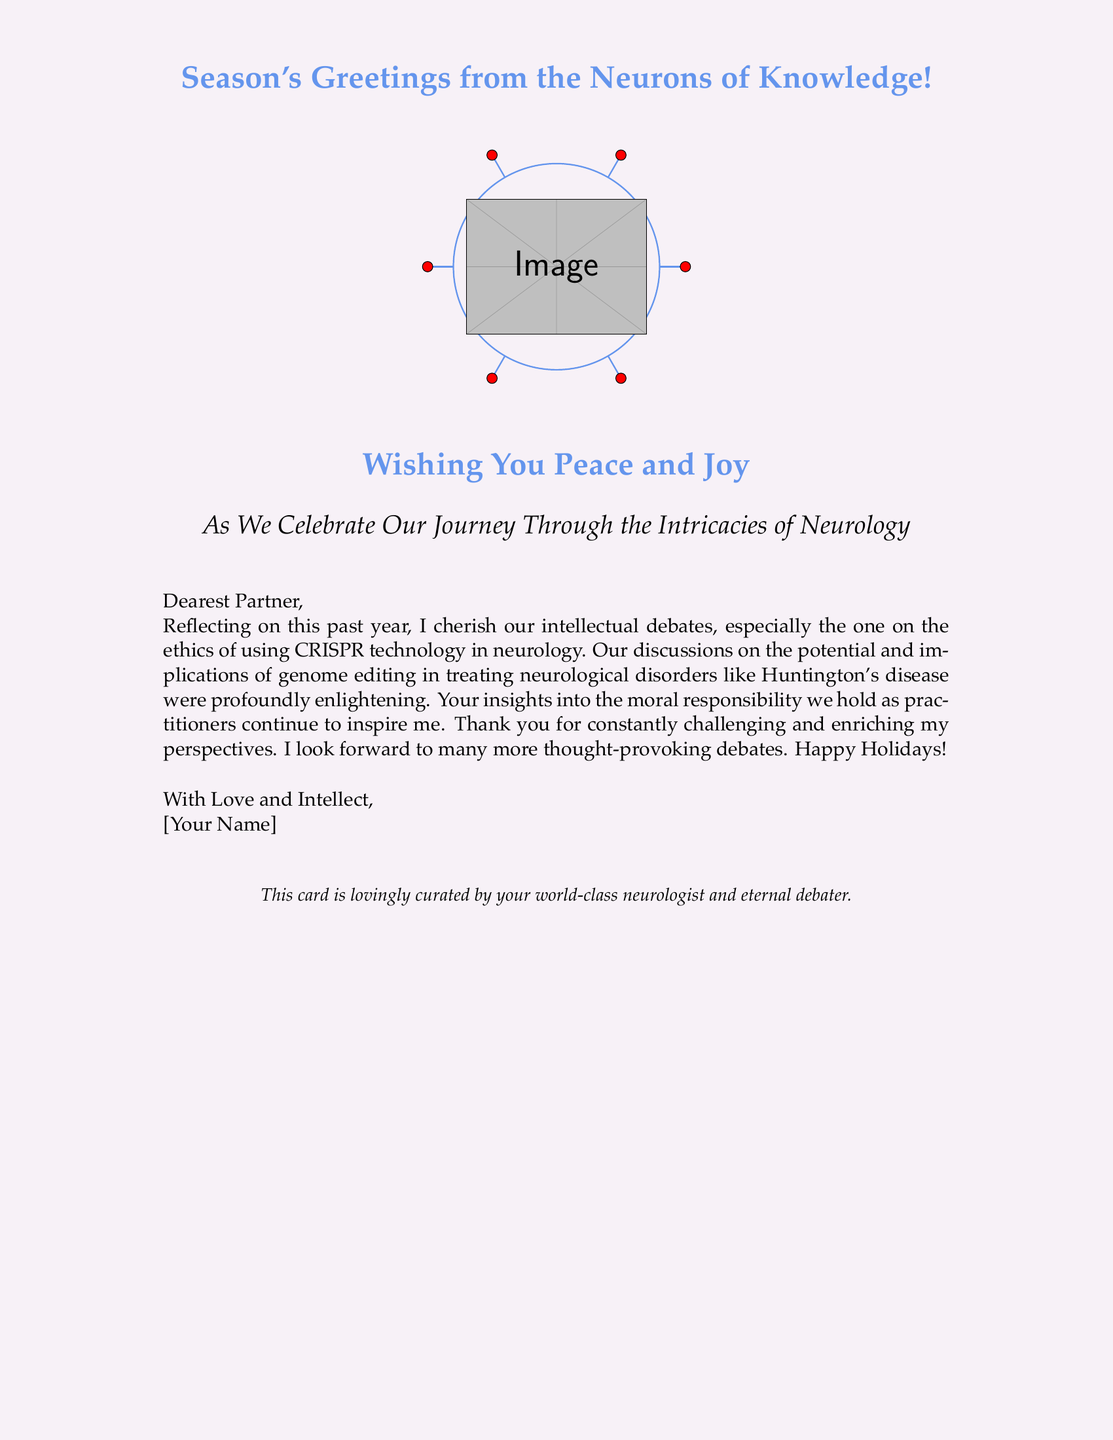What is the greeting in the card? The card contains a warm greeting wishing for peace and joy.
Answer: Peace and joy What color is used for the background? The background color is a light variation of brain color.
Answer: Braincolor!15 Who is the intended recipient of the card? The card is addressed to the author's partner, reflecting a personal relationship.
Answer: Partner What ethical topic is highlighted in the card? The author mentions a debate regarding the use of CRISPR technology in neurology.
Answer: CRISPR technology What neurological disorder was discussed in the ethical debate? The author references a specific neurological disorder in their discussion about CRISPR.
Answer: Huntington's disease What is the conclusion of the author's reflection? The author expresses gratitude for the partner's insights and looks forward to future discussions.
Answer: Thank you for constantly challenging and enriching my perspectives Which visual element is included in the card? The card features a festive imagery including brain cells wearing holiday hats.
Answer: Brain cells in holiday hats What type of relationship do the authors share? The card indicates that their relationship includes both personal and intellectual exchanges.
Answer: Intellectual debates What closing line indicates the author's profession? The conclusion of the card provides insight into the author's profession and personality.
Answer: World-class neurologist and eternal debater 